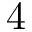Convert formula to latex. <formula><loc_0><loc_0><loc_500><loc_500>4</formula> 